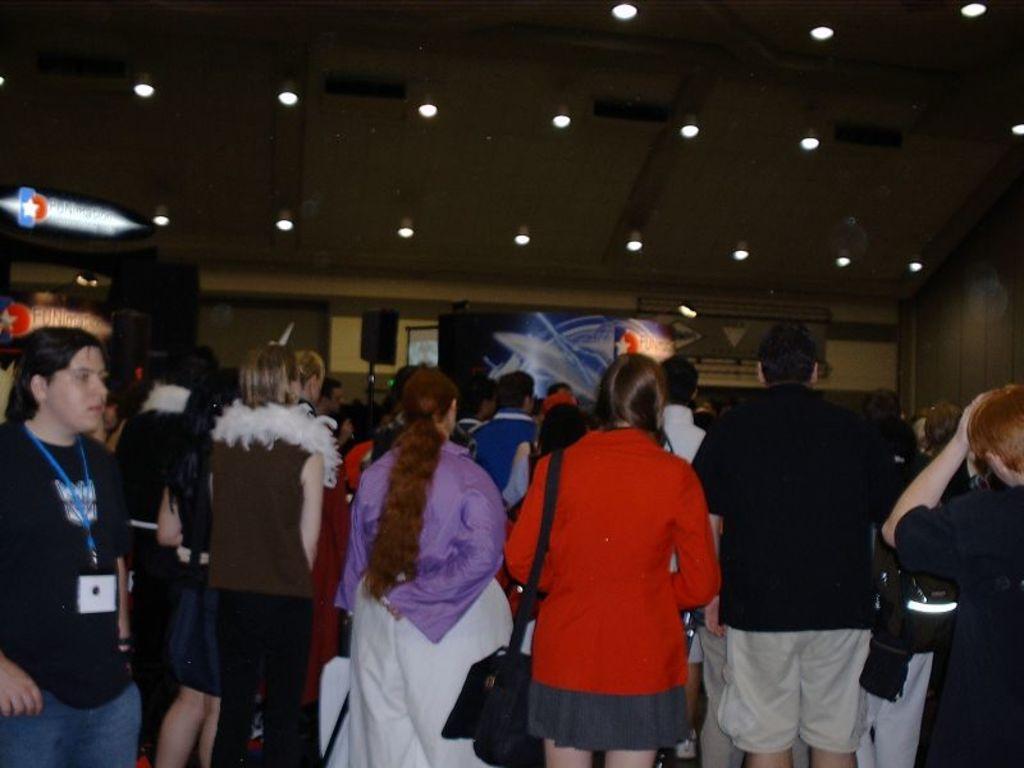Describe this image in one or two sentences. In this picture there are people in the center of the image and there are posters on the left and in the center of the image and there are lamps at the top side of the image. 